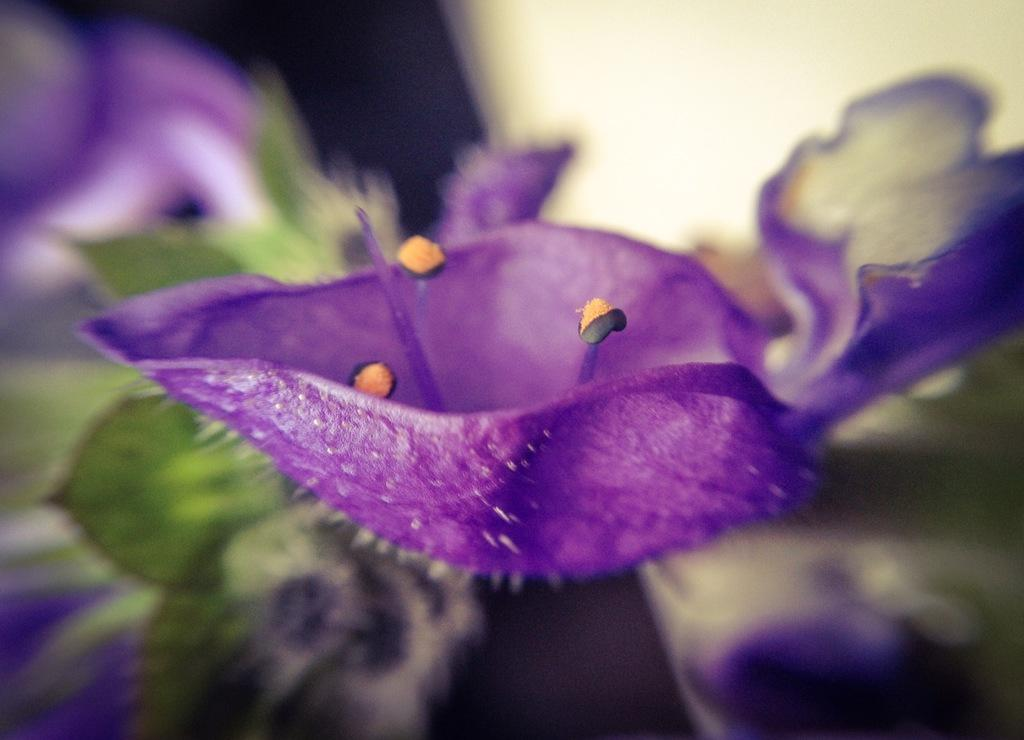What is present in the image? There are flowers in the image. Where are the flowers located? The flowers are on a plant. What colors can be seen on the flowers? The flowers are in purple and yellow colors. Can you describe the background of the image? The background of the image is blurred. How many rings can be seen on the bun in the image? There are no rings or buns present in the image; it features flowers on a plant. 